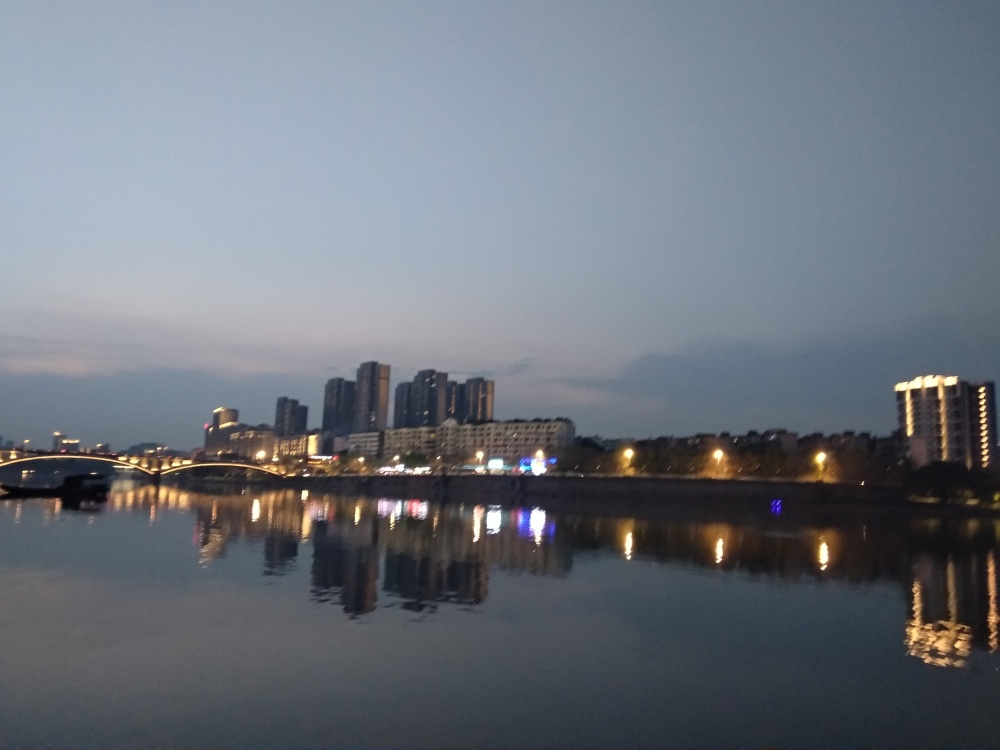What features in the image indicate it might be a city with significant development? The presence of high-rise buildings with modern architectural designs, the density of the buildings, and the well-lit bridge spanning the waterway suggest a developed urban area. The infrastructure's scale and the bright lit windows point to a significant human presence and activity, indicative of a city's development. 